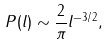Convert formula to latex. <formula><loc_0><loc_0><loc_500><loc_500>P ( l ) \sim \frac { 2 } { \pi } l ^ { - 3 / 2 } ,</formula> 